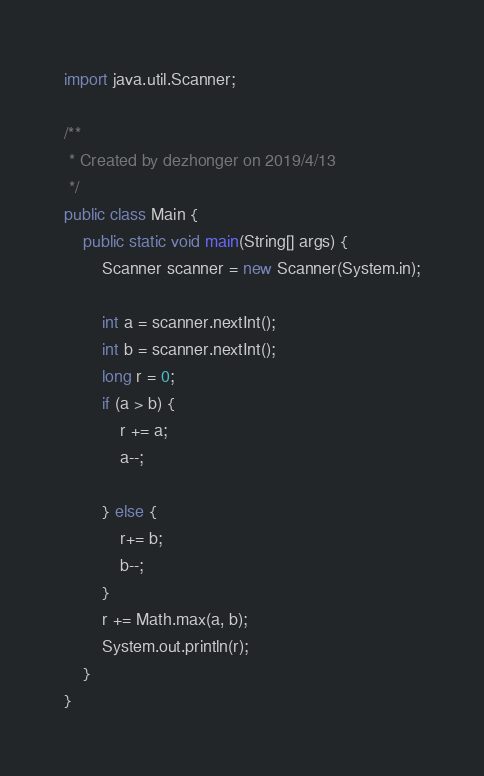<code> <loc_0><loc_0><loc_500><loc_500><_Java_>import java.util.Scanner;

/**
 * Created by dezhonger on 2019/4/13
 */
public class Main {
    public static void main(String[] args) {
        Scanner scanner = new Scanner(System.in);

        int a = scanner.nextInt();
        int b = scanner.nextInt();
        long r = 0;
        if (a > b) {
            r += a;
            a--;

        } else {
            r+= b;
            b--;
        }
        r += Math.max(a, b);
        System.out.println(r);
    }
}
</code> 